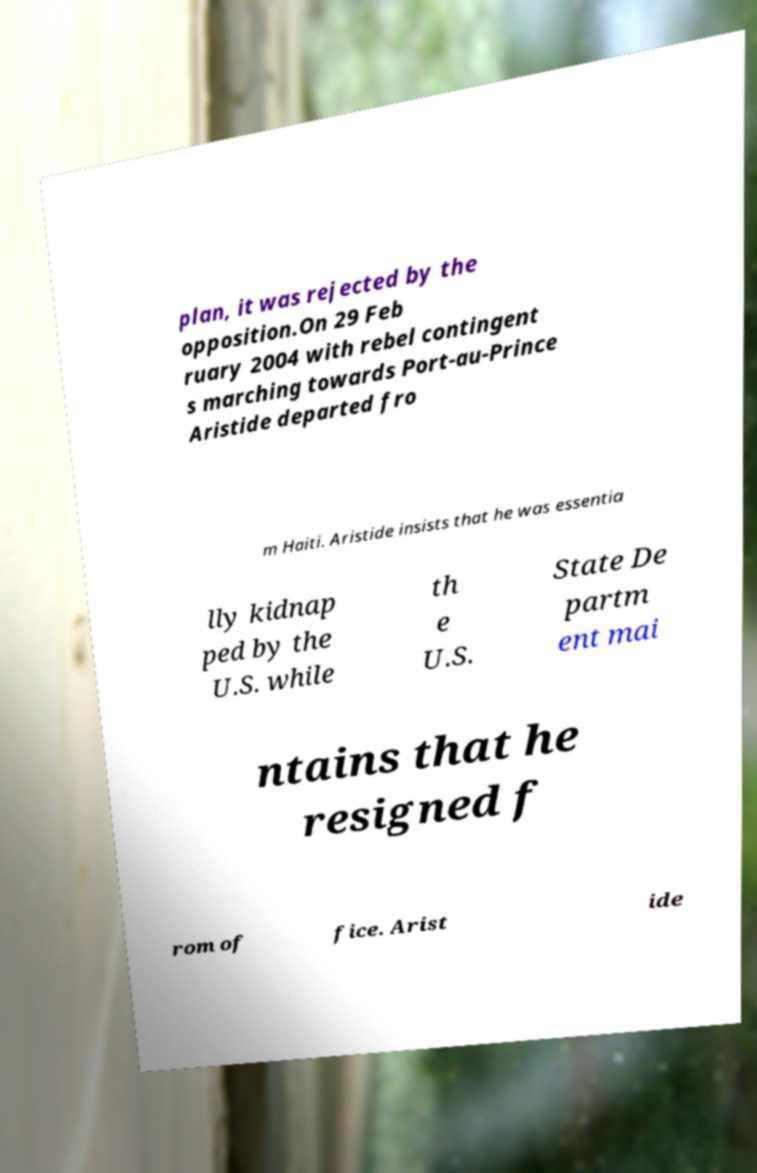Could you extract and type out the text from this image? plan, it was rejected by the opposition.On 29 Feb ruary 2004 with rebel contingent s marching towards Port-au-Prince Aristide departed fro m Haiti. Aristide insists that he was essentia lly kidnap ped by the U.S. while th e U.S. State De partm ent mai ntains that he resigned f rom of fice. Arist ide 